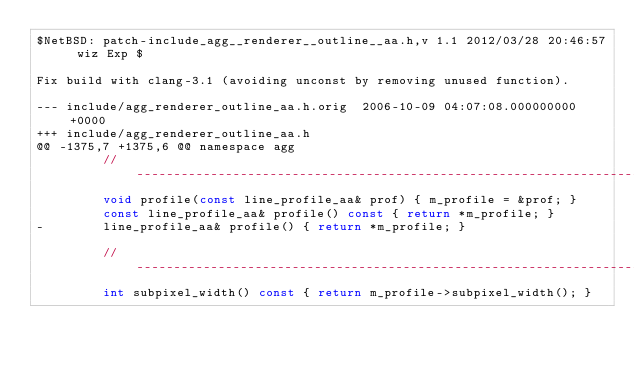<code> <loc_0><loc_0><loc_500><loc_500><_C_>$NetBSD: patch-include_agg__renderer__outline__aa.h,v 1.1 2012/03/28 20:46:57 wiz Exp $

Fix build with clang-3.1 (avoiding unconst by removing unused function).

--- include/agg_renderer_outline_aa.h.orig	2006-10-09 04:07:08.000000000 +0000
+++ include/agg_renderer_outline_aa.h
@@ -1375,7 +1375,6 @@ namespace agg
         //---------------------------------------------------------------------
         void profile(const line_profile_aa& prof) { m_profile = &prof; }
         const line_profile_aa& profile() const { return *m_profile; }
-        line_profile_aa& profile() { return *m_profile; }
 
         //---------------------------------------------------------------------
         int subpixel_width() const { return m_profile->subpixel_width(); }
</code> 